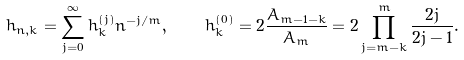<formula> <loc_0><loc_0><loc_500><loc_500>h _ { n , k } = \sum _ { j = 0 } ^ { \infty } h _ { k } ^ { ( j ) } n ^ { - j / m } , \quad h _ { k } ^ { ( 0 ) } = 2 \frac { A _ { m - 1 - k } } { A _ { m } } = 2 \prod _ { j = m - k } ^ { m } \frac { 2 j } { 2 j - 1 } .</formula> 